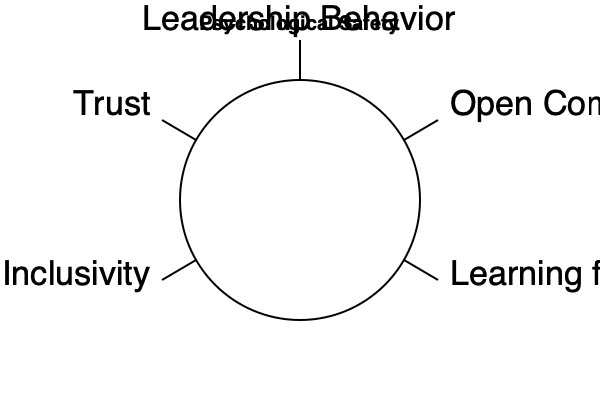Based on the mind map provided, which factor is centrally positioned and directly connected to all other elements contributing to psychological safety in an organization? To answer this question, let's analyze the mind map step-by-step:

1. The central concept of the mind map is "Psychological Safety," as indicated by the title at the top.

2. The mind map is structured as a circular diagram with five main elements:
   a. A central circle
   b. Four outer elements connected to the central circle

3. The four outer elements are:
   - Leadership Behavior
   - Open Communication
   - Learning from Failure
   - Inclusivity
   - Trust

4. These four elements are positioned around the circle and connected to it by lines, indicating their relationship to the central concept.

5. The central circle itself doesn't have a label, but its position and connections suggest it represents a core factor that links all other elements.

6. In the context of psychological safety, this central element likely represents the organizational culture or environment that encompasses and connects all other factors.

7. The positioning of this central element indicates that it's the key factor that directly influences and is influenced by all other elements of psychological safety.

Therefore, the centrally positioned factor that is directly connected to all other elements is the organizational culture or environment that fosters psychological safety.
Answer: Organizational culture 